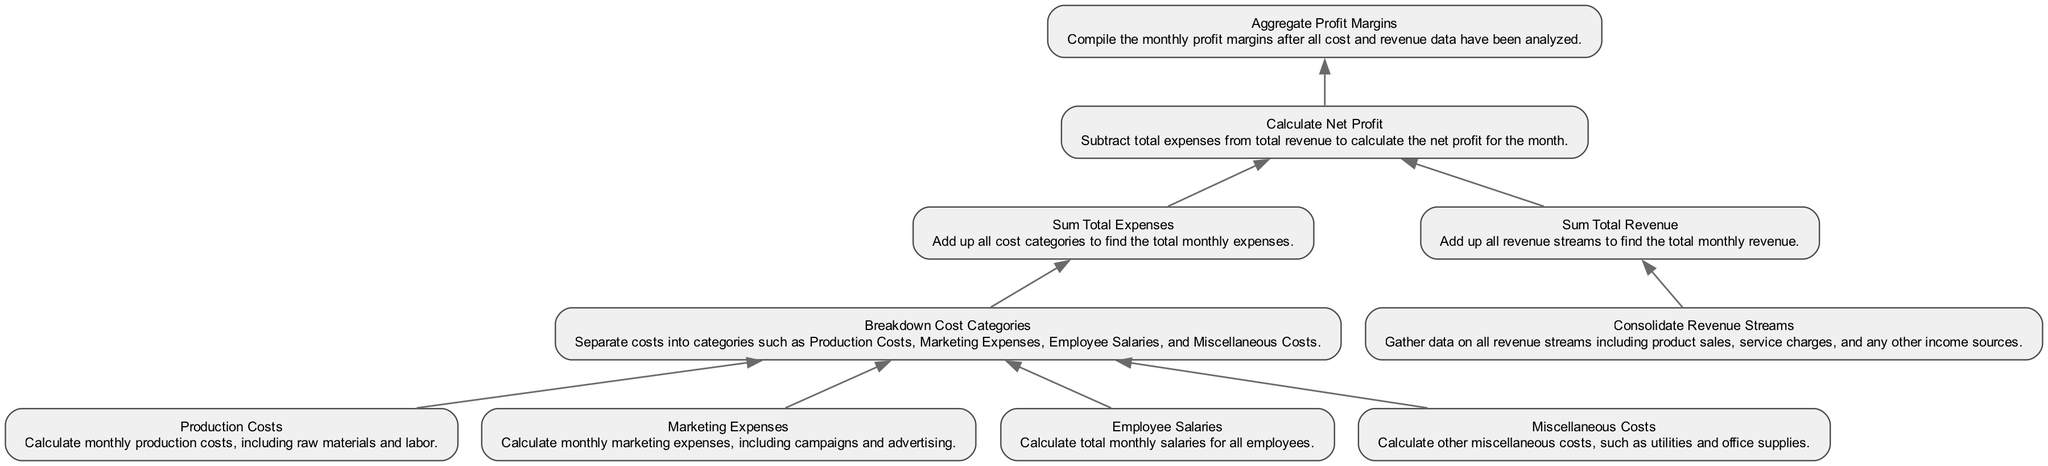What is the first step in the flowchart? The flowchart begins with "Production Costs," which is the initial action in the process and leads to breaking down cost categories.
Answer: Production Costs How many total expenses categories are broken down in the diagram? The diagram includes four distinct categories for expenses: Production Costs, Marketing Expenses, Employee Salaries, and Miscellaneous Costs.
Answer: Four What is the last action taken in the process? The final action in the flowchart is "Aggregate Profit Margins," which compiles the monthly profit margins after calculating net profit.
Answer: Aggregate Profit Margins Which node directly follows "Sum Total Revenue"? After "Sum Total Revenue," the next action is "Calculate Net Profit," where total expenses are subtracted from total revenue to find the net profit.
Answer: Calculate Net Profit How many edges connect different nodes in the diagram? The diagram has a total of eight edges that connect the various nodes, showing the flow from one action to the next within the analysis of monthly profit margins.
Answer: Eight What are the first two calculations needed to find net profit? The first two calculations are "Sum Total Revenue" and "Sum Total Expenses," which together provide the figures needed to calculate net profit by subtracting expenses from revenue.
Answer: Sum Total Revenue and Sum Total Expenses What type of costs is included under "Miscellaneous Costs"? Miscellaneous Costs include various other expenses not categorized under production, marketing, or salaries, such as utilities and office supplies.
Answer: Utilities and office supplies Which two nodes are required to complete the revenue calculation? To complete the revenue calculation, "Consolidate Revenue Streams" must precede "Sum Total Revenue," as it gathers all revenue data needed for that summary.
Answer: Consolidate Revenue Streams and Sum Total Revenue 